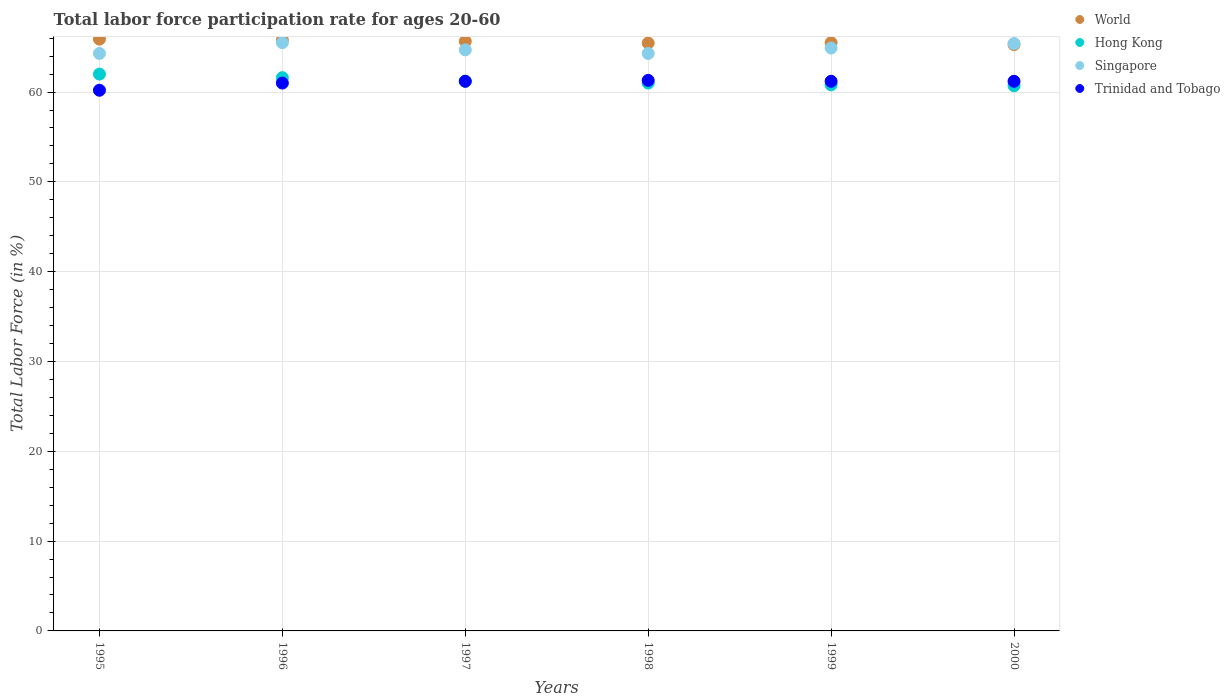How many different coloured dotlines are there?
Your response must be concise. 4. What is the labor force participation rate in World in 1997?
Ensure brevity in your answer.  65.64. Across all years, what is the maximum labor force participation rate in World?
Your answer should be compact. 65.89. Across all years, what is the minimum labor force participation rate in Singapore?
Provide a short and direct response. 64.3. What is the total labor force participation rate in World in the graph?
Your response must be concise. 393.55. What is the difference between the labor force participation rate in Hong Kong in 1995 and that in 1996?
Your answer should be compact. 0.4. What is the difference between the labor force participation rate in Singapore in 1998 and the labor force participation rate in Hong Kong in 1995?
Ensure brevity in your answer.  2.3. What is the average labor force participation rate in Hong Kong per year?
Offer a very short reply. 61.22. In the year 1995, what is the difference between the labor force participation rate in Singapore and labor force participation rate in Hong Kong?
Your answer should be compact. 2.3. What is the ratio of the labor force participation rate in World in 1995 to that in 1996?
Offer a very short reply. 1. Is the labor force participation rate in Singapore in 1995 less than that in 1998?
Provide a short and direct response. No. What is the difference between the highest and the second highest labor force participation rate in Singapore?
Your answer should be very brief. 0.1. What is the difference between the highest and the lowest labor force participation rate in Hong Kong?
Your response must be concise. 1.3. Is the sum of the labor force participation rate in World in 1995 and 1999 greater than the maximum labor force participation rate in Hong Kong across all years?
Your response must be concise. Yes. Is it the case that in every year, the sum of the labor force participation rate in Hong Kong and labor force participation rate in World  is greater than the sum of labor force participation rate in Singapore and labor force participation rate in Trinidad and Tobago?
Your answer should be compact. Yes. Is the labor force participation rate in Singapore strictly less than the labor force participation rate in World over the years?
Your answer should be compact. No. How many dotlines are there?
Keep it short and to the point. 4. Are the values on the major ticks of Y-axis written in scientific E-notation?
Provide a short and direct response. No. Does the graph contain any zero values?
Offer a terse response. No. Does the graph contain grids?
Ensure brevity in your answer.  Yes. How many legend labels are there?
Your answer should be very brief. 4. What is the title of the graph?
Your answer should be compact. Total labor force participation rate for ages 20-60. Does "Seychelles" appear as one of the legend labels in the graph?
Offer a terse response. No. What is the label or title of the X-axis?
Offer a very short reply. Years. What is the Total Labor Force (in %) in World in 1995?
Keep it short and to the point. 65.89. What is the Total Labor Force (in %) of Singapore in 1995?
Provide a short and direct response. 64.3. What is the Total Labor Force (in %) in Trinidad and Tobago in 1995?
Your answer should be compact. 60.2. What is the Total Labor Force (in %) of World in 1996?
Your answer should be compact. 65.78. What is the Total Labor Force (in %) in Hong Kong in 1996?
Offer a terse response. 61.6. What is the Total Labor Force (in %) of Singapore in 1996?
Offer a terse response. 65.5. What is the Total Labor Force (in %) of World in 1997?
Your response must be concise. 65.64. What is the Total Labor Force (in %) in Hong Kong in 1997?
Provide a short and direct response. 61.2. What is the Total Labor Force (in %) in Singapore in 1997?
Keep it short and to the point. 64.7. What is the Total Labor Force (in %) in Trinidad and Tobago in 1997?
Your answer should be compact. 61.2. What is the Total Labor Force (in %) of World in 1998?
Provide a short and direct response. 65.46. What is the Total Labor Force (in %) of Singapore in 1998?
Provide a short and direct response. 64.3. What is the Total Labor Force (in %) of Trinidad and Tobago in 1998?
Ensure brevity in your answer.  61.3. What is the Total Labor Force (in %) of World in 1999?
Give a very brief answer. 65.5. What is the Total Labor Force (in %) of Hong Kong in 1999?
Make the answer very short. 60.8. What is the Total Labor Force (in %) in Singapore in 1999?
Give a very brief answer. 64.9. What is the Total Labor Force (in %) of Trinidad and Tobago in 1999?
Give a very brief answer. 61.2. What is the Total Labor Force (in %) in World in 2000?
Ensure brevity in your answer.  65.29. What is the Total Labor Force (in %) in Hong Kong in 2000?
Provide a short and direct response. 60.7. What is the Total Labor Force (in %) in Singapore in 2000?
Offer a very short reply. 65.4. What is the Total Labor Force (in %) of Trinidad and Tobago in 2000?
Provide a succinct answer. 61.2. Across all years, what is the maximum Total Labor Force (in %) of World?
Provide a succinct answer. 65.89. Across all years, what is the maximum Total Labor Force (in %) of Hong Kong?
Your answer should be very brief. 62. Across all years, what is the maximum Total Labor Force (in %) in Singapore?
Your answer should be compact. 65.5. Across all years, what is the maximum Total Labor Force (in %) of Trinidad and Tobago?
Make the answer very short. 61.3. Across all years, what is the minimum Total Labor Force (in %) of World?
Your response must be concise. 65.29. Across all years, what is the minimum Total Labor Force (in %) in Hong Kong?
Offer a terse response. 60.7. Across all years, what is the minimum Total Labor Force (in %) of Singapore?
Your answer should be compact. 64.3. Across all years, what is the minimum Total Labor Force (in %) in Trinidad and Tobago?
Provide a short and direct response. 60.2. What is the total Total Labor Force (in %) in World in the graph?
Provide a succinct answer. 393.55. What is the total Total Labor Force (in %) in Hong Kong in the graph?
Give a very brief answer. 367.3. What is the total Total Labor Force (in %) of Singapore in the graph?
Provide a succinct answer. 389.1. What is the total Total Labor Force (in %) in Trinidad and Tobago in the graph?
Provide a short and direct response. 366.1. What is the difference between the Total Labor Force (in %) in World in 1995 and that in 1996?
Keep it short and to the point. 0.12. What is the difference between the Total Labor Force (in %) in Hong Kong in 1995 and that in 1996?
Offer a very short reply. 0.4. What is the difference between the Total Labor Force (in %) in Singapore in 1995 and that in 1996?
Your response must be concise. -1.2. What is the difference between the Total Labor Force (in %) in World in 1995 and that in 1997?
Your answer should be compact. 0.25. What is the difference between the Total Labor Force (in %) of Hong Kong in 1995 and that in 1997?
Your answer should be compact. 0.8. What is the difference between the Total Labor Force (in %) in Singapore in 1995 and that in 1997?
Your answer should be compact. -0.4. What is the difference between the Total Labor Force (in %) of World in 1995 and that in 1998?
Keep it short and to the point. 0.44. What is the difference between the Total Labor Force (in %) of Trinidad and Tobago in 1995 and that in 1998?
Your answer should be compact. -1.1. What is the difference between the Total Labor Force (in %) in World in 1995 and that in 1999?
Offer a very short reply. 0.39. What is the difference between the Total Labor Force (in %) in Singapore in 1995 and that in 1999?
Your answer should be compact. -0.6. What is the difference between the Total Labor Force (in %) in World in 1995 and that in 2000?
Give a very brief answer. 0.6. What is the difference between the Total Labor Force (in %) of Hong Kong in 1995 and that in 2000?
Offer a very short reply. 1.3. What is the difference between the Total Labor Force (in %) of Singapore in 1995 and that in 2000?
Keep it short and to the point. -1.1. What is the difference between the Total Labor Force (in %) of World in 1996 and that in 1997?
Offer a very short reply. 0.13. What is the difference between the Total Labor Force (in %) in Hong Kong in 1996 and that in 1997?
Give a very brief answer. 0.4. What is the difference between the Total Labor Force (in %) in Singapore in 1996 and that in 1997?
Your response must be concise. 0.8. What is the difference between the Total Labor Force (in %) in Trinidad and Tobago in 1996 and that in 1997?
Your response must be concise. -0.2. What is the difference between the Total Labor Force (in %) of World in 1996 and that in 1998?
Keep it short and to the point. 0.32. What is the difference between the Total Labor Force (in %) in Hong Kong in 1996 and that in 1998?
Provide a succinct answer. 0.6. What is the difference between the Total Labor Force (in %) of Singapore in 1996 and that in 1998?
Give a very brief answer. 1.2. What is the difference between the Total Labor Force (in %) in Trinidad and Tobago in 1996 and that in 1998?
Offer a terse response. -0.3. What is the difference between the Total Labor Force (in %) of World in 1996 and that in 1999?
Provide a short and direct response. 0.28. What is the difference between the Total Labor Force (in %) in Singapore in 1996 and that in 1999?
Make the answer very short. 0.6. What is the difference between the Total Labor Force (in %) of Trinidad and Tobago in 1996 and that in 1999?
Ensure brevity in your answer.  -0.2. What is the difference between the Total Labor Force (in %) of World in 1996 and that in 2000?
Your answer should be very brief. 0.49. What is the difference between the Total Labor Force (in %) in World in 1997 and that in 1998?
Your answer should be very brief. 0.19. What is the difference between the Total Labor Force (in %) of Singapore in 1997 and that in 1998?
Offer a terse response. 0.4. What is the difference between the Total Labor Force (in %) in World in 1997 and that in 1999?
Your answer should be very brief. 0.14. What is the difference between the Total Labor Force (in %) in World in 1997 and that in 2000?
Offer a terse response. 0.36. What is the difference between the Total Labor Force (in %) of Hong Kong in 1997 and that in 2000?
Your answer should be very brief. 0.5. What is the difference between the Total Labor Force (in %) in Singapore in 1997 and that in 2000?
Give a very brief answer. -0.7. What is the difference between the Total Labor Force (in %) of World in 1998 and that in 1999?
Make the answer very short. -0.04. What is the difference between the Total Labor Force (in %) of World in 1998 and that in 2000?
Your response must be concise. 0.17. What is the difference between the Total Labor Force (in %) in World in 1999 and that in 2000?
Your answer should be very brief. 0.21. What is the difference between the Total Labor Force (in %) in Singapore in 1999 and that in 2000?
Provide a succinct answer. -0.5. What is the difference between the Total Labor Force (in %) of Trinidad and Tobago in 1999 and that in 2000?
Your answer should be compact. 0. What is the difference between the Total Labor Force (in %) in World in 1995 and the Total Labor Force (in %) in Hong Kong in 1996?
Provide a succinct answer. 4.29. What is the difference between the Total Labor Force (in %) in World in 1995 and the Total Labor Force (in %) in Singapore in 1996?
Ensure brevity in your answer.  0.39. What is the difference between the Total Labor Force (in %) of World in 1995 and the Total Labor Force (in %) of Trinidad and Tobago in 1996?
Provide a succinct answer. 4.89. What is the difference between the Total Labor Force (in %) of World in 1995 and the Total Labor Force (in %) of Hong Kong in 1997?
Provide a short and direct response. 4.69. What is the difference between the Total Labor Force (in %) of World in 1995 and the Total Labor Force (in %) of Singapore in 1997?
Provide a short and direct response. 1.19. What is the difference between the Total Labor Force (in %) of World in 1995 and the Total Labor Force (in %) of Trinidad and Tobago in 1997?
Give a very brief answer. 4.69. What is the difference between the Total Labor Force (in %) of Hong Kong in 1995 and the Total Labor Force (in %) of Singapore in 1997?
Give a very brief answer. -2.7. What is the difference between the Total Labor Force (in %) in Hong Kong in 1995 and the Total Labor Force (in %) in Trinidad and Tobago in 1997?
Offer a very short reply. 0.8. What is the difference between the Total Labor Force (in %) of World in 1995 and the Total Labor Force (in %) of Hong Kong in 1998?
Provide a succinct answer. 4.89. What is the difference between the Total Labor Force (in %) in World in 1995 and the Total Labor Force (in %) in Singapore in 1998?
Your response must be concise. 1.59. What is the difference between the Total Labor Force (in %) in World in 1995 and the Total Labor Force (in %) in Trinidad and Tobago in 1998?
Offer a terse response. 4.59. What is the difference between the Total Labor Force (in %) of Singapore in 1995 and the Total Labor Force (in %) of Trinidad and Tobago in 1998?
Make the answer very short. 3. What is the difference between the Total Labor Force (in %) of World in 1995 and the Total Labor Force (in %) of Hong Kong in 1999?
Make the answer very short. 5.09. What is the difference between the Total Labor Force (in %) of World in 1995 and the Total Labor Force (in %) of Singapore in 1999?
Offer a very short reply. 0.99. What is the difference between the Total Labor Force (in %) in World in 1995 and the Total Labor Force (in %) in Trinidad and Tobago in 1999?
Your response must be concise. 4.69. What is the difference between the Total Labor Force (in %) in Hong Kong in 1995 and the Total Labor Force (in %) in Singapore in 1999?
Your answer should be compact. -2.9. What is the difference between the Total Labor Force (in %) in Singapore in 1995 and the Total Labor Force (in %) in Trinidad and Tobago in 1999?
Give a very brief answer. 3.1. What is the difference between the Total Labor Force (in %) in World in 1995 and the Total Labor Force (in %) in Hong Kong in 2000?
Give a very brief answer. 5.19. What is the difference between the Total Labor Force (in %) of World in 1995 and the Total Labor Force (in %) of Singapore in 2000?
Your answer should be compact. 0.49. What is the difference between the Total Labor Force (in %) in World in 1995 and the Total Labor Force (in %) in Trinidad and Tobago in 2000?
Provide a short and direct response. 4.69. What is the difference between the Total Labor Force (in %) in Hong Kong in 1995 and the Total Labor Force (in %) in Singapore in 2000?
Give a very brief answer. -3.4. What is the difference between the Total Labor Force (in %) of Singapore in 1995 and the Total Labor Force (in %) of Trinidad and Tobago in 2000?
Offer a terse response. 3.1. What is the difference between the Total Labor Force (in %) in World in 1996 and the Total Labor Force (in %) in Hong Kong in 1997?
Provide a short and direct response. 4.58. What is the difference between the Total Labor Force (in %) in World in 1996 and the Total Labor Force (in %) in Singapore in 1997?
Your response must be concise. 1.08. What is the difference between the Total Labor Force (in %) of World in 1996 and the Total Labor Force (in %) of Trinidad and Tobago in 1997?
Keep it short and to the point. 4.58. What is the difference between the Total Labor Force (in %) of Singapore in 1996 and the Total Labor Force (in %) of Trinidad and Tobago in 1997?
Your answer should be compact. 4.3. What is the difference between the Total Labor Force (in %) of World in 1996 and the Total Labor Force (in %) of Hong Kong in 1998?
Provide a short and direct response. 4.78. What is the difference between the Total Labor Force (in %) of World in 1996 and the Total Labor Force (in %) of Singapore in 1998?
Provide a succinct answer. 1.48. What is the difference between the Total Labor Force (in %) in World in 1996 and the Total Labor Force (in %) in Trinidad and Tobago in 1998?
Offer a very short reply. 4.48. What is the difference between the Total Labor Force (in %) of Hong Kong in 1996 and the Total Labor Force (in %) of Trinidad and Tobago in 1998?
Provide a short and direct response. 0.3. What is the difference between the Total Labor Force (in %) of Singapore in 1996 and the Total Labor Force (in %) of Trinidad and Tobago in 1998?
Keep it short and to the point. 4.2. What is the difference between the Total Labor Force (in %) of World in 1996 and the Total Labor Force (in %) of Hong Kong in 1999?
Offer a very short reply. 4.98. What is the difference between the Total Labor Force (in %) of World in 1996 and the Total Labor Force (in %) of Singapore in 1999?
Make the answer very short. 0.88. What is the difference between the Total Labor Force (in %) of World in 1996 and the Total Labor Force (in %) of Trinidad and Tobago in 1999?
Offer a terse response. 4.58. What is the difference between the Total Labor Force (in %) of Hong Kong in 1996 and the Total Labor Force (in %) of Trinidad and Tobago in 1999?
Your response must be concise. 0.4. What is the difference between the Total Labor Force (in %) of World in 1996 and the Total Labor Force (in %) of Hong Kong in 2000?
Provide a succinct answer. 5.08. What is the difference between the Total Labor Force (in %) of World in 1996 and the Total Labor Force (in %) of Singapore in 2000?
Make the answer very short. 0.38. What is the difference between the Total Labor Force (in %) of World in 1996 and the Total Labor Force (in %) of Trinidad and Tobago in 2000?
Make the answer very short. 4.58. What is the difference between the Total Labor Force (in %) of Hong Kong in 1996 and the Total Labor Force (in %) of Singapore in 2000?
Ensure brevity in your answer.  -3.8. What is the difference between the Total Labor Force (in %) in Hong Kong in 1996 and the Total Labor Force (in %) in Trinidad and Tobago in 2000?
Provide a short and direct response. 0.4. What is the difference between the Total Labor Force (in %) in Singapore in 1996 and the Total Labor Force (in %) in Trinidad and Tobago in 2000?
Your answer should be compact. 4.3. What is the difference between the Total Labor Force (in %) of World in 1997 and the Total Labor Force (in %) of Hong Kong in 1998?
Keep it short and to the point. 4.64. What is the difference between the Total Labor Force (in %) in World in 1997 and the Total Labor Force (in %) in Singapore in 1998?
Provide a succinct answer. 1.34. What is the difference between the Total Labor Force (in %) in World in 1997 and the Total Labor Force (in %) in Trinidad and Tobago in 1998?
Make the answer very short. 4.34. What is the difference between the Total Labor Force (in %) in Hong Kong in 1997 and the Total Labor Force (in %) in Singapore in 1998?
Your response must be concise. -3.1. What is the difference between the Total Labor Force (in %) of World in 1997 and the Total Labor Force (in %) of Hong Kong in 1999?
Offer a very short reply. 4.84. What is the difference between the Total Labor Force (in %) in World in 1997 and the Total Labor Force (in %) in Singapore in 1999?
Give a very brief answer. 0.74. What is the difference between the Total Labor Force (in %) of World in 1997 and the Total Labor Force (in %) of Trinidad and Tobago in 1999?
Offer a terse response. 4.44. What is the difference between the Total Labor Force (in %) of Hong Kong in 1997 and the Total Labor Force (in %) of Singapore in 1999?
Provide a succinct answer. -3.7. What is the difference between the Total Labor Force (in %) of Hong Kong in 1997 and the Total Labor Force (in %) of Trinidad and Tobago in 1999?
Give a very brief answer. 0. What is the difference between the Total Labor Force (in %) of Singapore in 1997 and the Total Labor Force (in %) of Trinidad and Tobago in 1999?
Offer a very short reply. 3.5. What is the difference between the Total Labor Force (in %) of World in 1997 and the Total Labor Force (in %) of Hong Kong in 2000?
Give a very brief answer. 4.94. What is the difference between the Total Labor Force (in %) in World in 1997 and the Total Labor Force (in %) in Singapore in 2000?
Offer a terse response. 0.24. What is the difference between the Total Labor Force (in %) of World in 1997 and the Total Labor Force (in %) of Trinidad and Tobago in 2000?
Your answer should be very brief. 4.44. What is the difference between the Total Labor Force (in %) in World in 1998 and the Total Labor Force (in %) in Hong Kong in 1999?
Your response must be concise. 4.66. What is the difference between the Total Labor Force (in %) of World in 1998 and the Total Labor Force (in %) of Singapore in 1999?
Your answer should be very brief. 0.56. What is the difference between the Total Labor Force (in %) of World in 1998 and the Total Labor Force (in %) of Trinidad and Tobago in 1999?
Your response must be concise. 4.26. What is the difference between the Total Labor Force (in %) of Hong Kong in 1998 and the Total Labor Force (in %) of Trinidad and Tobago in 1999?
Your answer should be compact. -0.2. What is the difference between the Total Labor Force (in %) in Singapore in 1998 and the Total Labor Force (in %) in Trinidad and Tobago in 1999?
Make the answer very short. 3.1. What is the difference between the Total Labor Force (in %) in World in 1998 and the Total Labor Force (in %) in Hong Kong in 2000?
Make the answer very short. 4.76. What is the difference between the Total Labor Force (in %) in World in 1998 and the Total Labor Force (in %) in Singapore in 2000?
Your response must be concise. 0.06. What is the difference between the Total Labor Force (in %) in World in 1998 and the Total Labor Force (in %) in Trinidad and Tobago in 2000?
Keep it short and to the point. 4.26. What is the difference between the Total Labor Force (in %) of Hong Kong in 1998 and the Total Labor Force (in %) of Trinidad and Tobago in 2000?
Offer a very short reply. -0.2. What is the difference between the Total Labor Force (in %) in Singapore in 1998 and the Total Labor Force (in %) in Trinidad and Tobago in 2000?
Provide a short and direct response. 3.1. What is the difference between the Total Labor Force (in %) in World in 1999 and the Total Labor Force (in %) in Hong Kong in 2000?
Offer a terse response. 4.8. What is the difference between the Total Labor Force (in %) in World in 1999 and the Total Labor Force (in %) in Singapore in 2000?
Keep it short and to the point. 0.1. What is the difference between the Total Labor Force (in %) in World in 1999 and the Total Labor Force (in %) in Trinidad and Tobago in 2000?
Keep it short and to the point. 4.3. What is the difference between the Total Labor Force (in %) in Hong Kong in 1999 and the Total Labor Force (in %) in Trinidad and Tobago in 2000?
Offer a terse response. -0.4. What is the average Total Labor Force (in %) of World per year?
Ensure brevity in your answer.  65.59. What is the average Total Labor Force (in %) in Hong Kong per year?
Provide a short and direct response. 61.22. What is the average Total Labor Force (in %) in Singapore per year?
Your answer should be very brief. 64.85. What is the average Total Labor Force (in %) in Trinidad and Tobago per year?
Your answer should be compact. 61.02. In the year 1995, what is the difference between the Total Labor Force (in %) of World and Total Labor Force (in %) of Hong Kong?
Ensure brevity in your answer.  3.89. In the year 1995, what is the difference between the Total Labor Force (in %) in World and Total Labor Force (in %) in Singapore?
Provide a succinct answer. 1.59. In the year 1995, what is the difference between the Total Labor Force (in %) in World and Total Labor Force (in %) in Trinidad and Tobago?
Your answer should be compact. 5.69. In the year 1995, what is the difference between the Total Labor Force (in %) in Hong Kong and Total Labor Force (in %) in Singapore?
Give a very brief answer. -2.3. In the year 1995, what is the difference between the Total Labor Force (in %) in Singapore and Total Labor Force (in %) in Trinidad and Tobago?
Your response must be concise. 4.1. In the year 1996, what is the difference between the Total Labor Force (in %) in World and Total Labor Force (in %) in Hong Kong?
Your answer should be very brief. 4.18. In the year 1996, what is the difference between the Total Labor Force (in %) in World and Total Labor Force (in %) in Singapore?
Provide a succinct answer. 0.28. In the year 1996, what is the difference between the Total Labor Force (in %) of World and Total Labor Force (in %) of Trinidad and Tobago?
Make the answer very short. 4.78. In the year 1996, what is the difference between the Total Labor Force (in %) of Hong Kong and Total Labor Force (in %) of Singapore?
Give a very brief answer. -3.9. In the year 1996, what is the difference between the Total Labor Force (in %) in Hong Kong and Total Labor Force (in %) in Trinidad and Tobago?
Your answer should be compact. 0.6. In the year 1997, what is the difference between the Total Labor Force (in %) of World and Total Labor Force (in %) of Hong Kong?
Offer a very short reply. 4.44. In the year 1997, what is the difference between the Total Labor Force (in %) of World and Total Labor Force (in %) of Singapore?
Offer a terse response. 0.94. In the year 1997, what is the difference between the Total Labor Force (in %) of World and Total Labor Force (in %) of Trinidad and Tobago?
Provide a short and direct response. 4.44. In the year 1997, what is the difference between the Total Labor Force (in %) in Singapore and Total Labor Force (in %) in Trinidad and Tobago?
Make the answer very short. 3.5. In the year 1998, what is the difference between the Total Labor Force (in %) of World and Total Labor Force (in %) of Hong Kong?
Ensure brevity in your answer.  4.46. In the year 1998, what is the difference between the Total Labor Force (in %) of World and Total Labor Force (in %) of Singapore?
Your answer should be compact. 1.16. In the year 1998, what is the difference between the Total Labor Force (in %) in World and Total Labor Force (in %) in Trinidad and Tobago?
Your response must be concise. 4.16. In the year 1999, what is the difference between the Total Labor Force (in %) of World and Total Labor Force (in %) of Hong Kong?
Your answer should be compact. 4.7. In the year 1999, what is the difference between the Total Labor Force (in %) of World and Total Labor Force (in %) of Singapore?
Offer a very short reply. 0.6. In the year 1999, what is the difference between the Total Labor Force (in %) of World and Total Labor Force (in %) of Trinidad and Tobago?
Provide a succinct answer. 4.3. In the year 1999, what is the difference between the Total Labor Force (in %) in Hong Kong and Total Labor Force (in %) in Singapore?
Provide a succinct answer. -4.1. In the year 1999, what is the difference between the Total Labor Force (in %) in Hong Kong and Total Labor Force (in %) in Trinidad and Tobago?
Your answer should be very brief. -0.4. In the year 2000, what is the difference between the Total Labor Force (in %) of World and Total Labor Force (in %) of Hong Kong?
Make the answer very short. 4.59. In the year 2000, what is the difference between the Total Labor Force (in %) in World and Total Labor Force (in %) in Singapore?
Give a very brief answer. -0.11. In the year 2000, what is the difference between the Total Labor Force (in %) of World and Total Labor Force (in %) of Trinidad and Tobago?
Provide a succinct answer. 4.09. In the year 2000, what is the difference between the Total Labor Force (in %) in Hong Kong and Total Labor Force (in %) in Singapore?
Your response must be concise. -4.7. What is the ratio of the Total Labor Force (in %) of Hong Kong in 1995 to that in 1996?
Your response must be concise. 1.01. What is the ratio of the Total Labor Force (in %) in Singapore in 1995 to that in 1996?
Your answer should be very brief. 0.98. What is the ratio of the Total Labor Force (in %) of Trinidad and Tobago in 1995 to that in 1996?
Offer a terse response. 0.99. What is the ratio of the Total Labor Force (in %) of World in 1995 to that in 1997?
Your response must be concise. 1. What is the ratio of the Total Labor Force (in %) in Hong Kong in 1995 to that in 1997?
Offer a very short reply. 1.01. What is the ratio of the Total Labor Force (in %) in Trinidad and Tobago in 1995 to that in 1997?
Offer a terse response. 0.98. What is the ratio of the Total Labor Force (in %) in Hong Kong in 1995 to that in 1998?
Ensure brevity in your answer.  1.02. What is the ratio of the Total Labor Force (in %) in Trinidad and Tobago in 1995 to that in 1998?
Ensure brevity in your answer.  0.98. What is the ratio of the Total Labor Force (in %) of Hong Kong in 1995 to that in 1999?
Keep it short and to the point. 1.02. What is the ratio of the Total Labor Force (in %) in Trinidad and Tobago in 1995 to that in 1999?
Offer a terse response. 0.98. What is the ratio of the Total Labor Force (in %) of World in 1995 to that in 2000?
Your response must be concise. 1.01. What is the ratio of the Total Labor Force (in %) of Hong Kong in 1995 to that in 2000?
Ensure brevity in your answer.  1.02. What is the ratio of the Total Labor Force (in %) in Singapore in 1995 to that in 2000?
Give a very brief answer. 0.98. What is the ratio of the Total Labor Force (in %) of Trinidad and Tobago in 1995 to that in 2000?
Ensure brevity in your answer.  0.98. What is the ratio of the Total Labor Force (in %) of World in 1996 to that in 1997?
Offer a very short reply. 1. What is the ratio of the Total Labor Force (in %) of Hong Kong in 1996 to that in 1997?
Your response must be concise. 1.01. What is the ratio of the Total Labor Force (in %) in Singapore in 1996 to that in 1997?
Provide a short and direct response. 1.01. What is the ratio of the Total Labor Force (in %) of Trinidad and Tobago in 1996 to that in 1997?
Your response must be concise. 1. What is the ratio of the Total Labor Force (in %) of World in 1996 to that in 1998?
Your response must be concise. 1. What is the ratio of the Total Labor Force (in %) of Hong Kong in 1996 to that in 1998?
Offer a terse response. 1.01. What is the ratio of the Total Labor Force (in %) of Singapore in 1996 to that in 1998?
Give a very brief answer. 1.02. What is the ratio of the Total Labor Force (in %) in Trinidad and Tobago in 1996 to that in 1998?
Make the answer very short. 1. What is the ratio of the Total Labor Force (in %) in World in 1996 to that in 1999?
Keep it short and to the point. 1. What is the ratio of the Total Labor Force (in %) in Hong Kong in 1996 to that in 1999?
Offer a terse response. 1.01. What is the ratio of the Total Labor Force (in %) in Singapore in 1996 to that in 1999?
Your answer should be very brief. 1.01. What is the ratio of the Total Labor Force (in %) of World in 1996 to that in 2000?
Your answer should be compact. 1.01. What is the ratio of the Total Labor Force (in %) in Hong Kong in 1996 to that in 2000?
Give a very brief answer. 1.01. What is the ratio of the Total Labor Force (in %) of Singapore in 1996 to that in 2000?
Give a very brief answer. 1. What is the ratio of the Total Labor Force (in %) of Trinidad and Tobago in 1996 to that in 2000?
Provide a short and direct response. 1. What is the ratio of the Total Labor Force (in %) in Hong Kong in 1997 to that in 1998?
Keep it short and to the point. 1. What is the ratio of the Total Labor Force (in %) in Singapore in 1997 to that in 1998?
Give a very brief answer. 1.01. What is the ratio of the Total Labor Force (in %) in World in 1997 to that in 1999?
Ensure brevity in your answer.  1. What is the ratio of the Total Labor Force (in %) of Hong Kong in 1997 to that in 1999?
Provide a succinct answer. 1.01. What is the ratio of the Total Labor Force (in %) of Singapore in 1997 to that in 1999?
Keep it short and to the point. 1. What is the ratio of the Total Labor Force (in %) of Trinidad and Tobago in 1997 to that in 1999?
Provide a succinct answer. 1. What is the ratio of the Total Labor Force (in %) in World in 1997 to that in 2000?
Offer a very short reply. 1.01. What is the ratio of the Total Labor Force (in %) in Hong Kong in 1997 to that in 2000?
Make the answer very short. 1.01. What is the ratio of the Total Labor Force (in %) of Singapore in 1997 to that in 2000?
Ensure brevity in your answer.  0.99. What is the ratio of the Total Labor Force (in %) of Trinidad and Tobago in 1997 to that in 2000?
Keep it short and to the point. 1. What is the ratio of the Total Labor Force (in %) in World in 1998 to that in 1999?
Your response must be concise. 1. What is the ratio of the Total Labor Force (in %) in Hong Kong in 1998 to that in 1999?
Your answer should be very brief. 1. What is the ratio of the Total Labor Force (in %) of World in 1998 to that in 2000?
Provide a short and direct response. 1. What is the ratio of the Total Labor Force (in %) of Singapore in 1998 to that in 2000?
Your answer should be very brief. 0.98. What is the ratio of the Total Labor Force (in %) in Singapore in 1999 to that in 2000?
Offer a very short reply. 0.99. What is the difference between the highest and the second highest Total Labor Force (in %) in World?
Your answer should be compact. 0.12. What is the difference between the highest and the second highest Total Labor Force (in %) of Hong Kong?
Provide a short and direct response. 0.4. What is the difference between the highest and the lowest Total Labor Force (in %) of World?
Make the answer very short. 0.6. What is the difference between the highest and the lowest Total Labor Force (in %) of Hong Kong?
Your answer should be compact. 1.3. What is the difference between the highest and the lowest Total Labor Force (in %) in Trinidad and Tobago?
Provide a short and direct response. 1.1. 